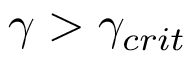<formula> <loc_0><loc_0><loc_500><loc_500>\gamma > \gamma _ { c r i t }</formula> 